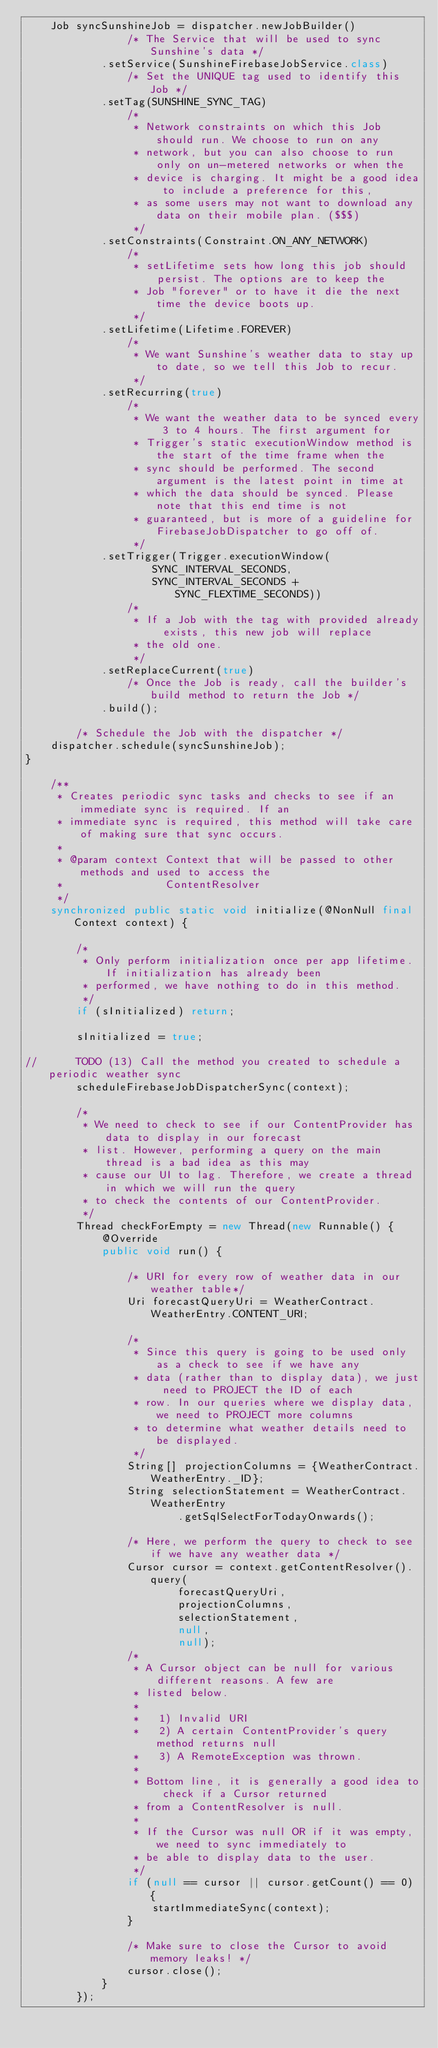<code> <loc_0><loc_0><loc_500><loc_500><_Java_>    Job syncSunshineJob = dispatcher.newJobBuilder()
                /* The Service that will be used to sync Sunshine's data */
            .setService(SunshineFirebaseJobService.class)
                /* Set the UNIQUE tag used to identify this Job */
            .setTag(SUNSHINE_SYNC_TAG)
                /*
                 * Network constraints on which this Job should run. We choose to run on any
                 * network, but you can also choose to run only on un-metered networks or when the
                 * device is charging. It might be a good idea to include a preference for this,
                 * as some users may not want to download any data on their mobile plan. ($$$)
                 */
            .setConstraints(Constraint.ON_ANY_NETWORK)
                /*
                 * setLifetime sets how long this job should persist. The options are to keep the
                 * Job "forever" or to have it die the next time the device boots up.
                 */
            .setLifetime(Lifetime.FOREVER)
                /*
                 * We want Sunshine's weather data to stay up to date, so we tell this Job to recur.
                 */
            .setRecurring(true)
                /*
                 * We want the weather data to be synced every 3 to 4 hours. The first argument for
                 * Trigger's static executionWindow method is the start of the time frame when the
                 * sync should be performed. The second argument is the latest point in time at
                 * which the data should be synced. Please note that this end time is not
                 * guaranteed, but is more of a guideline for FirebaseJobDispatcher to go off of.
                 */
            .setTrigger(Trigger.executionWindow(
                    SYNC_INTERVAL_SECONDS,
                    SYNC_INTERVAL_SECONDS + SYNC_FLEXTIME_SECONDS))
                /*
                 * If a Job with the tag with provided already exists, this new job will replace
                 * the old one.
                 */
            .setReplaceCurrent(true)
                /* Once the Job is ready, call the builder's build method to return the Job */
            .build();

        /* Schedule the Job with the dispatcher */
    dispatcher.schedule(syncSunshineJob);
}

    /**
     * Creates periodic sync tasks and checks to see if an immediate sync is required. If an
     * immediate sync is required, this method will take care of making sure that sync occurs.
     *
     * @param context Context that will be passed to other methods and used to access the
     *                ContentResolver
     */
    synchronized public static void initialize(@NonNull final Context context) {

        /*
         * Only perform initialization once per app lifetime. If initialization has already been
         * performed, we have nothing to do in this method.
         */
        if (sInitialized) return;

        sInitialized = true;

//      TODO (13) Call the method you created to schedule a periodic weather sync
        scheduleFirebaseJobDispatcherSync(context);

        /*
         * We need to check to see if our ContentProvider has data to display in our forecast
         * list. However, performing a query on the main thread is a bad idea as this may
         * cause our UI to lag. Therefore, we create a thread in which we will run the query
         * to check the contents of our ContentProvider.
         */
        Thread checkForEmpty = new Thread(new Runnable() {
            @Override
            public void run() {

                /* URI for every row of weather data in our weather table*/
                Uri forecastQueryUri = WeatherContract.WeatherEntry.CONTENT_URI;

                /*
                 * Since this query is going to be used only as a check to see if we have any
                 * data (rather than to display data), we just need to PROJECT the ID of each
                 * row. In our queries where we display data, we need to PROJECT more columns
                 * to determine what weather details need to be displayed.
                 */
                String[] projectionColumns = {WeatherContract.WeatherEntry._ID};
                String selectionStatement = WeatherContract.WeatherEntry
                        .getSqlSelectForTodayOnwards();

                /* Here, we perform the query to check to see if we have any weather data */
                Cursor cursor = context.getContentResolver().query(
                        forecastQueryUri,
                        projectionColumns,
                        selectionStatement,
                        null,
                        null);
                /*
                 * A Cursor object can be null for various different reasons. A few are
                 * listed below.
                 *
                 *   1) Invalid URI
                 *   2) A certain ContentProvider's query method returns null
                 *   3) A RemoteException was thrown.
                 *
                 * Bottom line, it is generally a good idea to check if a Cursor returned
                 * from a ContentResolver is null.
                 *
                 * If the Cursor was null OR if it was empty, we need to sync immediately to
                 * be able to display data to the user.
                 */
                if (null == cursor || cursor.getCount() == 0) {
                    startImmediateSync(context);
                }

                /* Make sure to close the Cursor to avoid memory leaks! */
                cursor.close();
            }
        });
</code> 